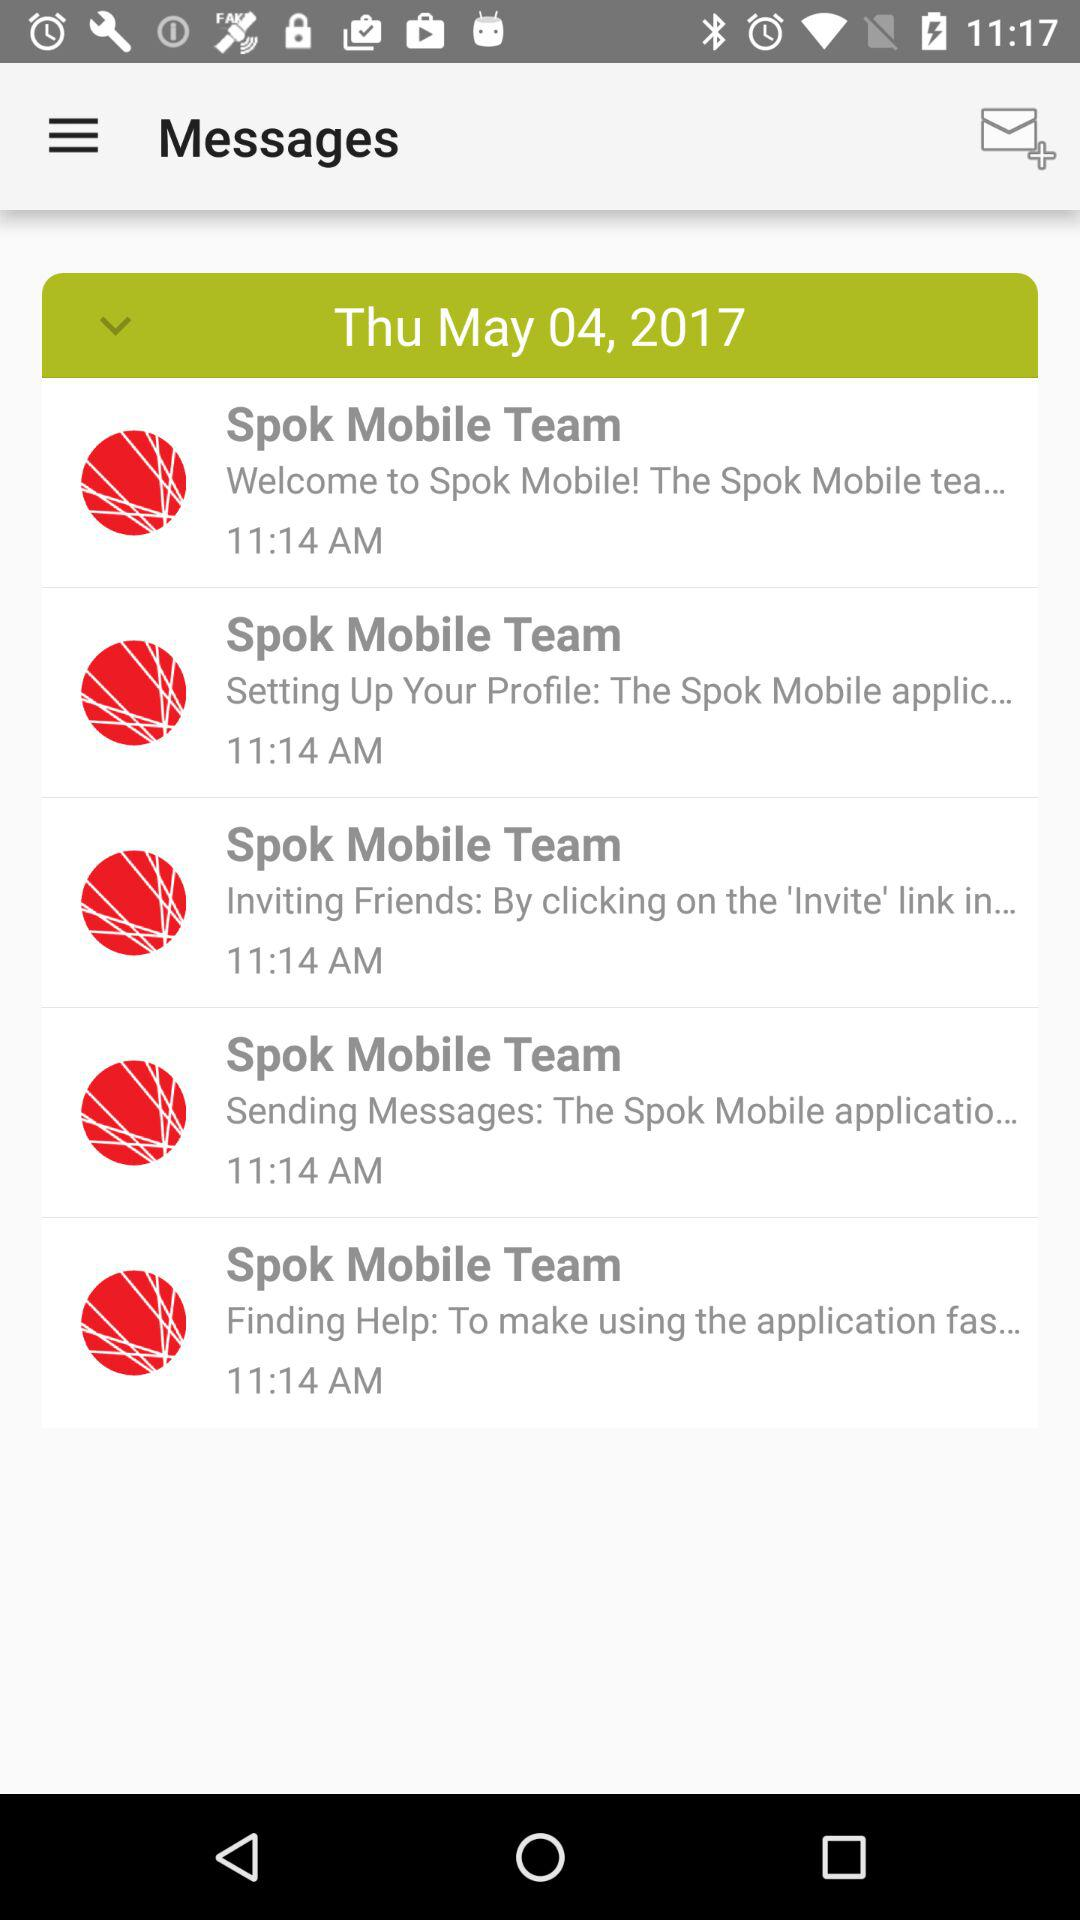What is the time of the message "Setting Up Your Profile"? The time is 11:14 AM. 